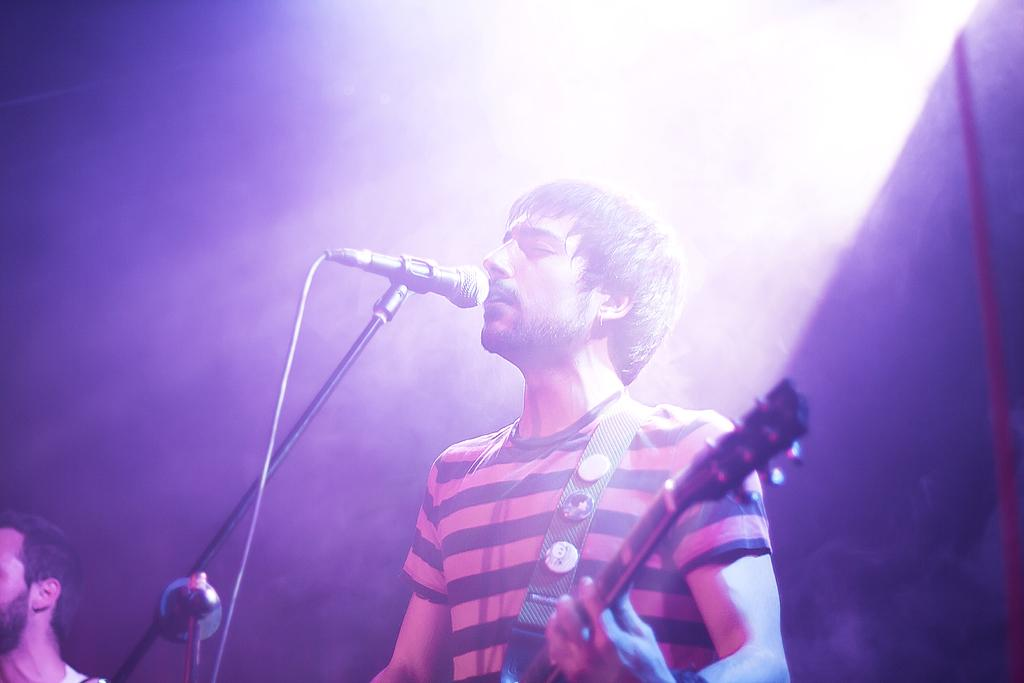What type of event is taking place in the image? It is a music concert. What instrument is the man holding in the image? The man is holding a guitar. What is the man doing with the guitar? The man is playing the guitar. What is the man doing while playing the guitar? The man is singing. Is there anyone else present in the image? Yes, there is another person standing beside the guitarist. What can be seen in the background of the image? There is a light in the background. What type of chess piece is the man using as a guitar pick in the image? There is no chess piece or reference to chess in the image; the man is using a guitar pick to play the guitar. How much salt is on the guitarist's hand in the image? There is no salt present in the image; the man's hand is holding a guitar pick. 